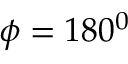<formula> <loc_0><loc_0><loc_500><loc_500>\phi = 1 8 0 ^ { 0 }</formula> 